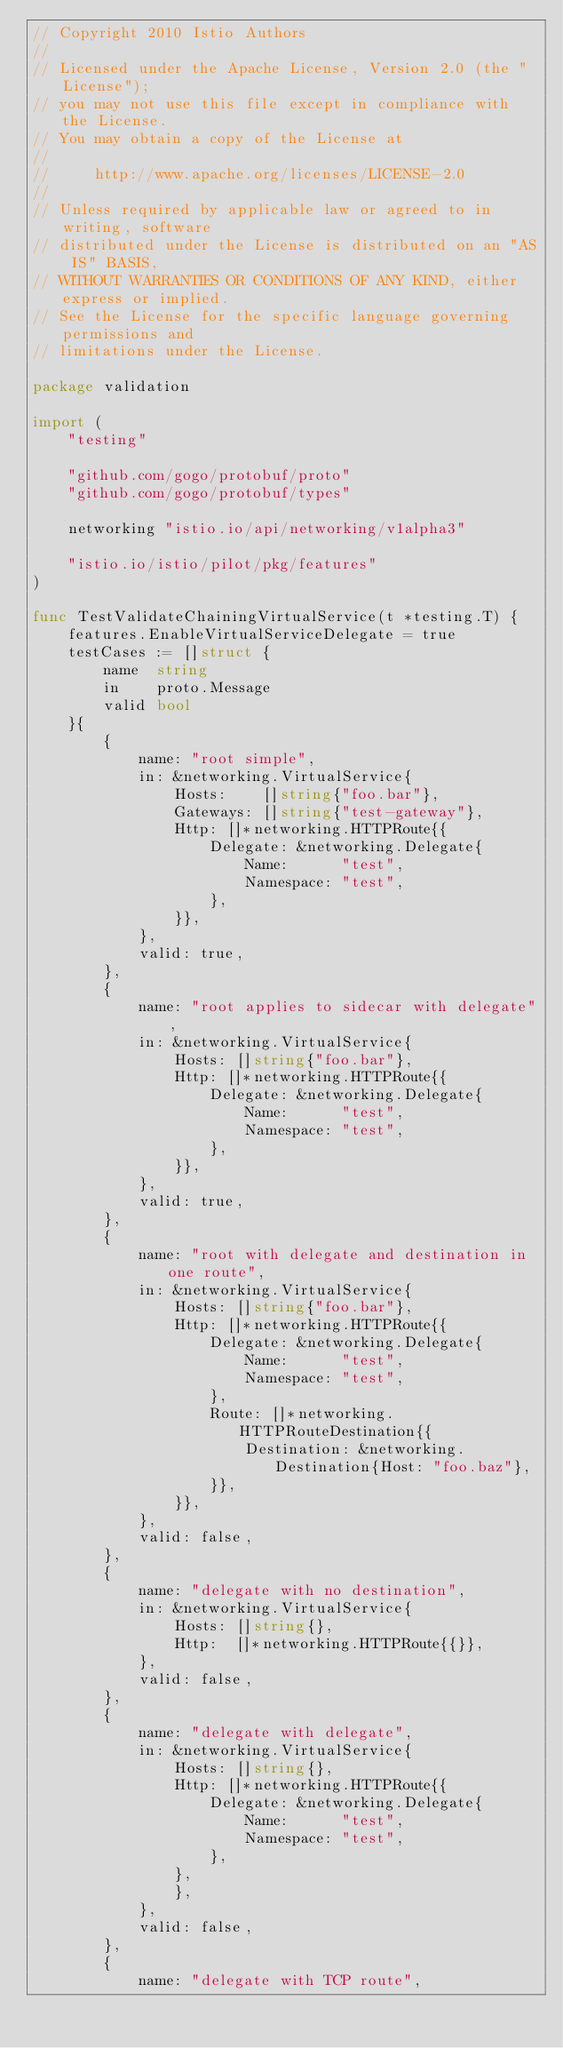Convert code to text. <code><loc_0><loc_0><loc_500><loc_500><_Go_>// Copyright 2010 Istio Authors
//
// Licensed under the Apache License, Version 2.0 (the "License");
// you may not use this file except in compliance with the License.
// You may obtain a copy of the License at
//
//     http://www.apache.org/licenses/LICENSE-2.0
//
// Unless required by applicable law or agreed to in writing, software
// distributed under the License is distributed on an "AS IS" BASIS,
// WITHOUT WARRANTIES OR CONDITIONS OF ANY KIND, either express or implied.
// See the License for the specific language governing permissions and
// limitations under the License.

package validation

import (
	"testing"

	"github.com/gogo/protobuf/proto"
	"github.com/gogo/protobuf/types"

	networking "istio.io/api/networking/v1alpha3"

	"istio.io/istio/pilot/pkg/features"
)

func TestValidateChainingVirtualService(t *testing.T) {
	features.EnableVirtualServiceDelegate = true
	testCases := []struct {
		name  string
		in    proto.Message
		valid bool
	}{
		{
			name: "root simple",
			in: &networking.VirtualService{
				Hosts:    []string{"foo.bar"},
				Gateways: []string{"test-gateway"},
				Http: []*networking.HTTPRoute{{
					Delegate: &networking.Delegate{
						Name:      "test",
						Namespace: "test",
					},
				}},
			},
			valid: true,
		},
		{
			name: "root applies to sidecar with delegate",
			in: &networking.VirtualService{
				Hosts: []string{"foo.bar"},
				Http: []*networking.HTTPRoute{{
					Delegate: &networking.Delegate{
						Name:      "test",
						Namespace: "test",
					},
				}},
			},
			valid: true,
		},
		{
			name: "root with delegate and destination in one route",
			in: &networking.VirtualService{
				Hosts: []string{"foo.bar"},
				Http: []*networking.HTTPRoute{{
					Delegate: &networking.Delegate{
						Name:      "test",
						Namespace: "test",
					},
					Route: []*networking.HTTPRouteDestination{{
						Destination: &networking.Destination{Host: "foo.baz"},
					}},
				}},
			},
			valid: false,
		},
		{
			name: "delegate with no destination",
			in: &networking.VirtualService{
				Hosts: []string{},
				Http:  []*networking.HTTPRoute{{}},
			},
			valid: false,
		},
		{
			name: "delegate with delegate",
			in: &networking.VirtualService{
				Hosts: []string{},
				Http: []*networking.HTTPRoute{{
					Delegate: &networking.Delegate{
						Name:      "test",
						Namespace: "test",
					},
				},
				},
			},
			valid: false,
		},
		{
			name: "delegate with TCP route",</code> 